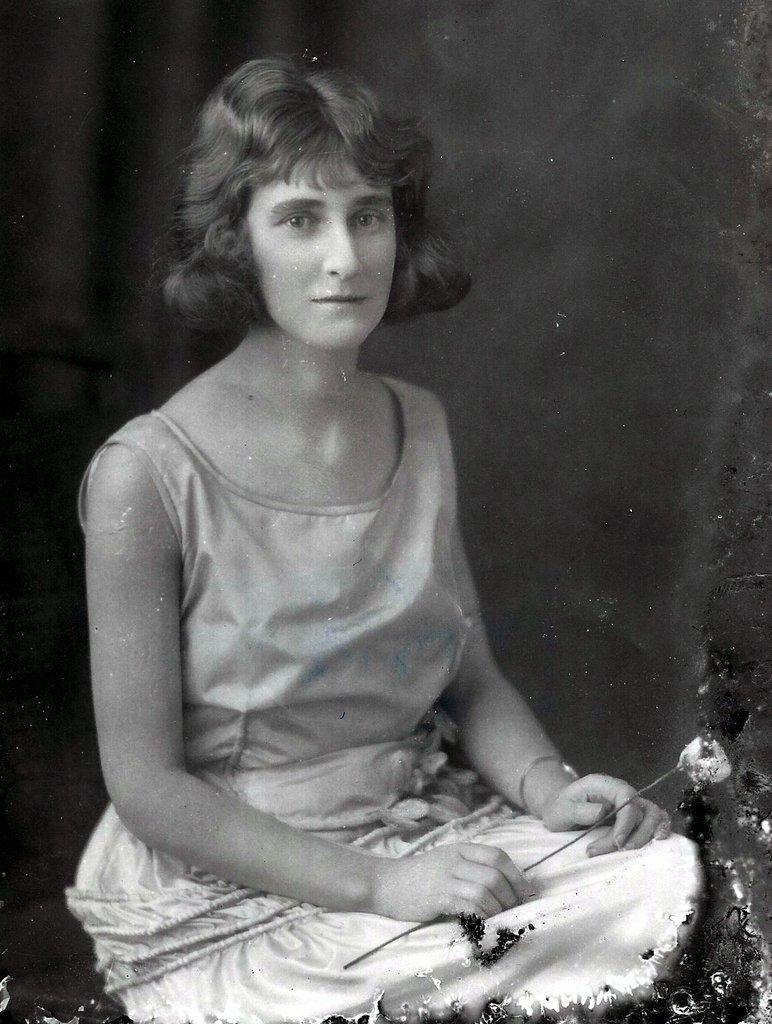Could you give a brief overview of what you see in this image? In this picture there is a man who is wearing t-shirt and short. She is holding a flower. In the back I can see the darkness. 